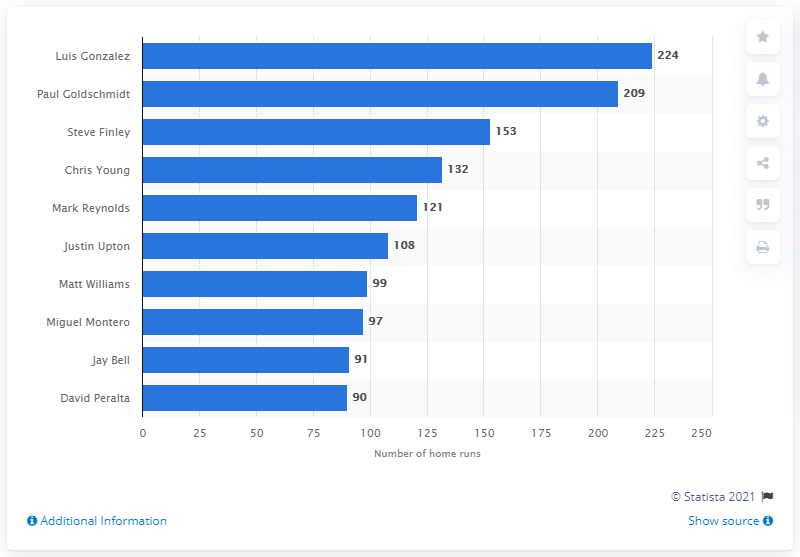Outline some significant characteristics in this image. Luis Gonzalez has hit 224 home runs. Luis Gonzalez holds the record for the most home runs in Arizona Diamondbacks franchise history. 